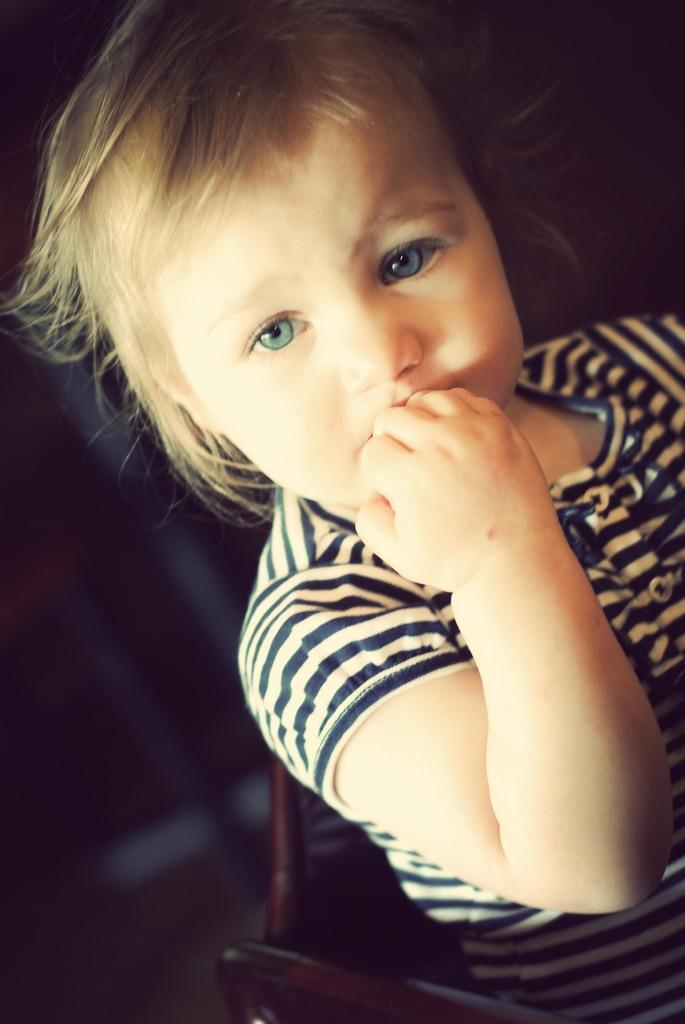What is the main subject of the image? There is a baby in the image. Can you describe the baby's appearance? The baby has blond hair and blue eyes. What is the baby wearing? The baby is wearing a white and blue striped t-shirt. What is the baby doing in the image? The baby is sitting on a chair. What is the cause of the water flowing in the image? There is no water flowing in the image; it only features a baby sitting on a chair. 